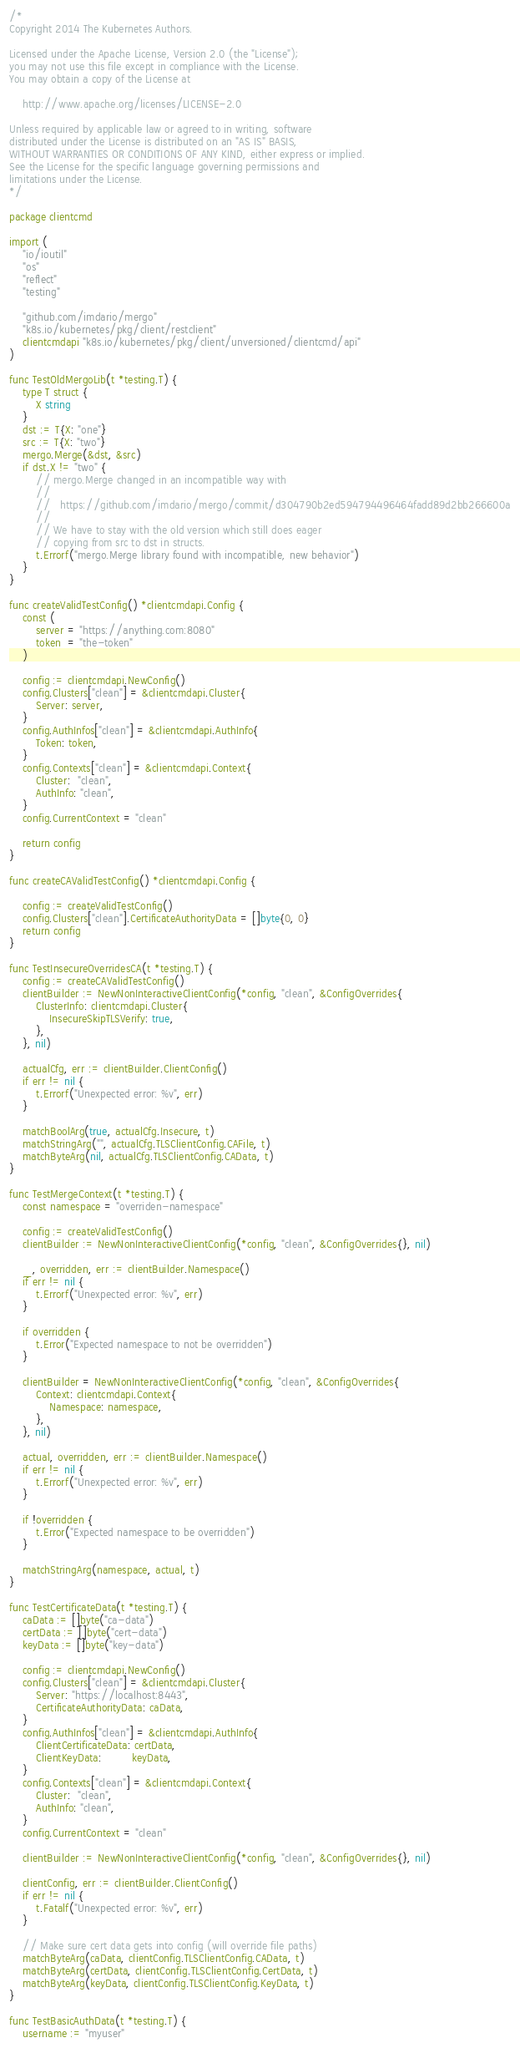<code> <loc_0><loc_0><loc_500><loc_500><_Go_>/*
Copyright 2014 The Kubernetes Authors.

Licensed under the Apache License, Version 2.0 (the "License");
you may not use this file except in compliance with the License.
You may obtain a copy of the License at

    http://www.apache.org/licenses/LICENSE-2.0

Unless required by applicable law or agreed to in writing, software
distributed under the License is distributed on an "AS IS" BASIS,
WITHOUT WARRANTIES OR CONDITIONS OF ANY KIND, either express or implied.
See the License for the specific language governing permissions and
limitations under the License.
*/

package clientcmd

import (
	"io/ioutil"
	"os"
	"reflect"
	"testing"

	"github.com/imdario/mergo"
	"k8s.io/kubernetes/pkg/client/restclient"
	clientcmdapi "k8s.io/kubernetes/pkg/client/unversioned/clientcmd/api"
)

func TestOldMergoLib(t *testing.T) {
	type T struct {
		X string
	}
	dst := T{X: "one"}
	src := T{X: "two"}
	mergo.Merge(&dst, &src)
	if dst.X != "two" {
		// mergo.Merge changed in an incompatible way with
		//
		//   https://github.com/imdario/mergo/commit/d304790b2ed594794496464fadd89d2bb266600a
		//
		// We have to stay with the old version which still does eager
		// copying from src to dst in structs.
		t.Errorf("mergo.Merge library found with incompatible, new behavior")
	}
}

func createValidTestConfig() *clientcmdapi.Config {
	const (
		server = "https://anything.com:8080"
		token  = "the-token"
	)

	config := clientcmdapi.NewConfig()
	config.Clusters["clean"] = &clientcmdapi.Cluster{
		Server: server,
	}
	config.AuthInfos["clean"] = &clientcmdapi.AuthInfo{
		Token: token,
	}
	config.Contexts["clean"] = &clientcmdapi.Context{
		Cluster:  "clean",
		AuthInfo: "clean",
	}
	config.CurrentContext = "clean"

	return config
}

func createCAValidTestConfig() *clientcmdapi.Config {

	config := createValidTestConfig()
	config.Clusters["clean"].CertificateAuthorityData = []byte{0, 0}
	return config
}

func TestInsecureOverridesCA(t *testing.T) {
	config := createCAValidTestConfig()
	clientBuilder := NewNonInteractiveClientConfig(*config, "clean", &ConfigOverrides{
		ClusterInfo: clientcmdapi.Cluster{
			InsecureSkipTLSVerify: true,
		},
	}, nil)

	actualCfg, err := clientBuilder.ClientConfig()
	if err != nil {
		t.Errorf("Unexpected error: %v", err)
	}

	matchBoolArg(true, actualCfg.Insecure, t)
	matchStringArg("", actualCfg.TLSClientConfig.CAFile, t)
	matchByteArg(nil, actualCfg.TLSClientConfig.CAData, t)
}

func TestMergeContext(t *testing.T) {
	const namespace = "overriden-namespace"

	config := createValidTestConfig()
	clientBuilder := NewNonInteractiveClientConfig(*config, "clean", &ConfigOverrides{}, nil)

	_, overridden, err := clientBuilder.Namespace()
	if err != nil {
		t.Errorf("Unexpected error: %v", err)
	}

	if overridden {
		t.Error("Expected namespace to not be overridden")
	}

	clientBuilder = NewNonInteractiveClientConfig(*config, "clean", &ConfigOverrides{
		Context: clientcmdapi.Context{
			Namespace: namespace,
		},
	}, nil)

	actual, overridden, err := clientBuilder.Namespace()
	if err != nil {
		t.Errorf("Unexpected error: %v", err)
	}

	if !overridden {
		t.Error("Expected namespace to be overridden")
	}

	matchStringArg(namespace, actual, t)
}

func TestCertificateData(t *testing.T) {
	caData := []byte("ca-data")
	certData := []byte("cert-data")
	keyData := []byte("key-data")

	config := clientcmdapi.NewConfig()
	config.Clusters["clean"] = &clientcmdapi.Cluster{
		Server: "https://localhost:8443",
		CertificateAuthorityData: caData,
	}
	config.AuthInfos["clean"] = &clientcmdapi.AuthInfo{
		ClientCertificateData: certData,
		ClientKeyData:         keyData,
	}
	config.Contexts["clean"] = &clientcmdapi.Context{
		Cluster:  "clean",
		AuthInfo: "clean",
	}
	config.CurrentContext = "clean"

	clientBuilder := NewNonInteractiveClientConfig(*config, "clean", &ConfigOverrides{}, nil)

	clientConfig, err := clientBuilder.ClientConfig()
	if err != nil {
		t.Fatalf("Unexpected error: %v", err)
	}

	// Make sure cert data gets into config (will override file paths)
	matchByteArg(caData, clientConfig.TLSClientConfig.CAData, t)
	matchByteArg(certData, clientConfig.TLSClientConfig.CertData, t)
	matchByteArg(keyData, clientConfig.TLSClientConfig.KeyData, t)
}

func TestBasicAuthData(t *testing.T) {
	username := "myuser"</code> 